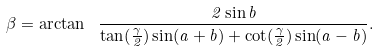<formula> <loc_0><loc_0><loc_500><loc_500>\beta = \arctan \ { \frac { 2 \sin b } { \tan ( { \frac { \gamma } { 2 } } ) \sin ( a + b ) + \cot ( { \frac { \gamma } { 2 } } ) \sin ( a - b ) } } .</formula> 